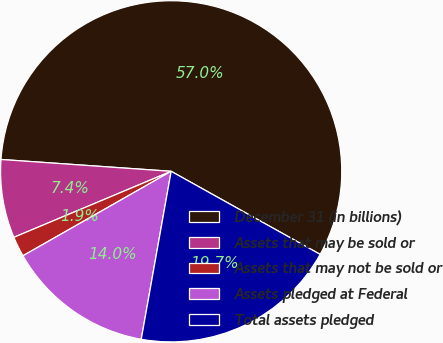Convert chart. <chart><loc_0><loc_0><loc_500><loc_500><pie_chart><fcel>December 31 (in billions)<fcel>Assets that may be sold or<fcel>Assets that may not be sold or<fcel>Assets pledged at Federal<fcel>Total assets pledged<nl><fcel>56.99%<fcel>7.43%<fcel>1.92%<fcel>13.95%<fcel>19.71%<nl></chart> 